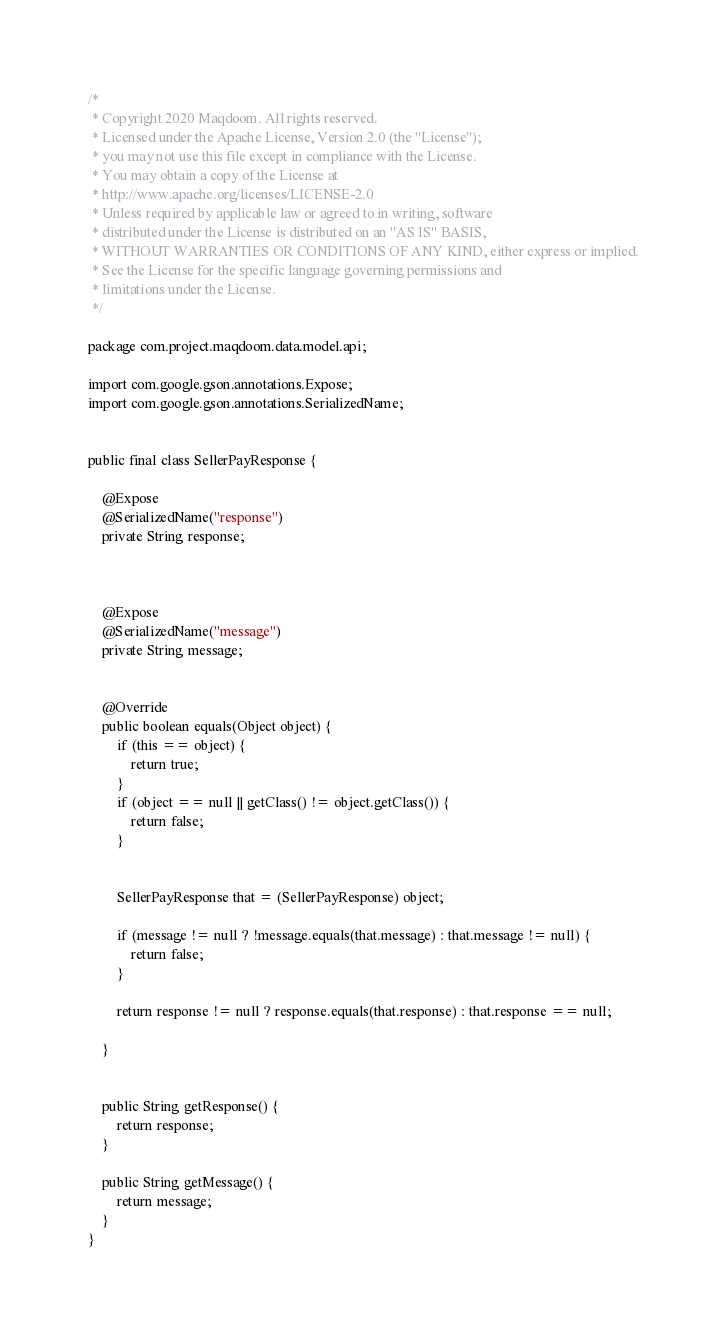<code> <loc_0><loc_0><loc_500><loc_500><_Java_>/*
 * Copyright 2020 Maqdoom. All rights reserved.
 * Licensed under the Apache License, Version 2.0 (the "License");
 * you may not use this file except in compliance with the License.
 * You may obtain a copy of the License at
 * http://www.apache.org/licenses/LICENSE-2.0
 * Unless required by applicable law or agreed to in writing, software
 * distributed under the License is distributed on an "AS IS" BASIS,
 * WITHOUT WARRANTIES OR CONDITIONS OF ANY KIND, either express or implied.
 * See the License for the specific language governing permissions and
 * limitations under the License.
 */

package com.project.maqdoom.data.model.api;

import com.google.gson.annotations.Expose;
import com.google.gson.annotations.SerializedName;


public final class SellerPayResponse {

    @Expose
    @SerializedName("response")
    private String response;



    @Expose
    @SerializedName("message")
    private String message;


    @Override
    public boolean equals(Object object) {
        if (this == object) {
            return true;
        }
        if (object == null || getClass() != object.getClass()) {
            return false;
        }


        SellerPayResponse that = (SellerPayResponse) object;

        if (message != null ? !message.equals(that.message) : that.message != null) {
            return false;
        }

        return response != null ? response.equals(that.response) : that.response == null;

    }


    public String getResponse() {
        return response;
    }

    public String getMessage() {
        return message;
    }
}
</code> 